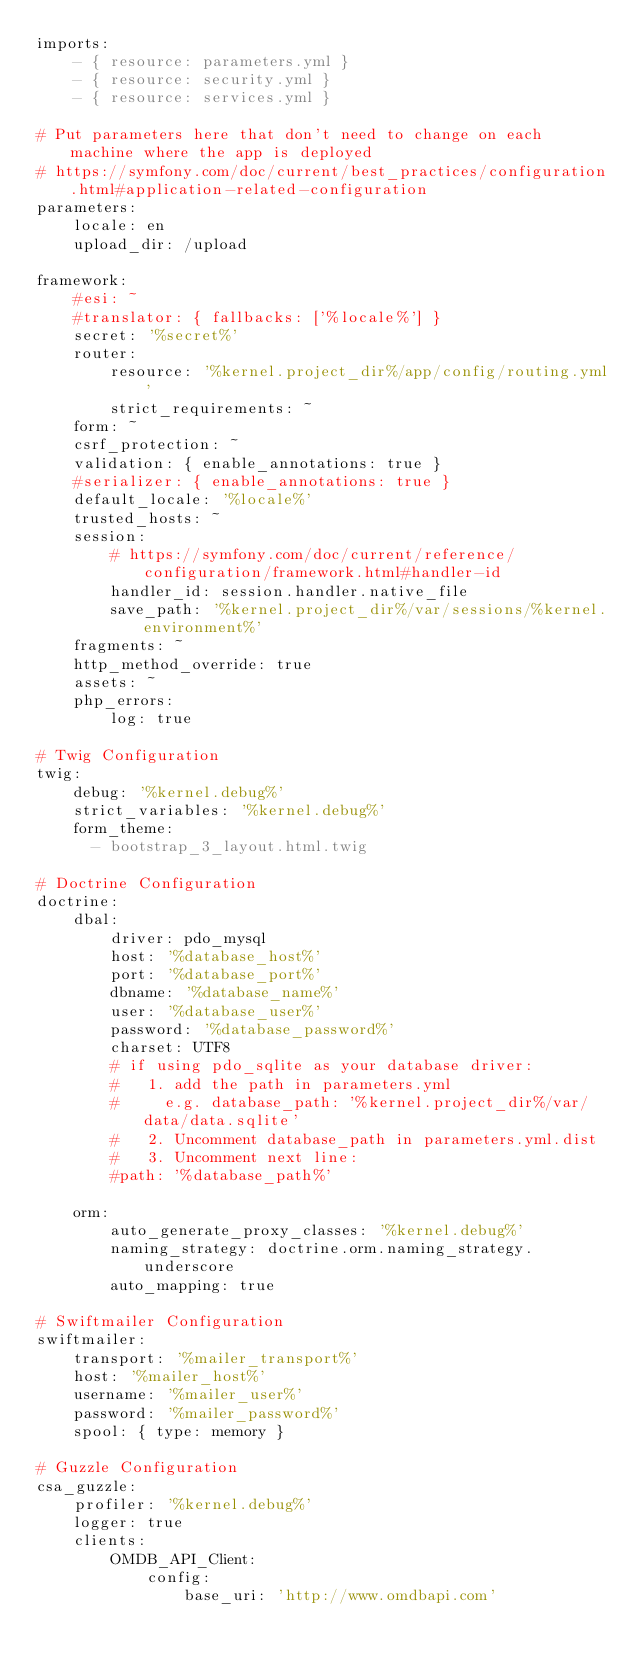Convert code to text. <code><loc_0><loc_0><loc_500><loc_500><_YAML_>imports:
    - { resource: parameters.yml }
    - { resource: security.yml }
    - { resource: services.yml }

# Put parameters here that don't need to change on each machine where the app is deployed
# https://symfony.com/doc/current/best_practices/configuration.html#application-related-configuration
parameters:
    locale: en
    upload_dir: /upload

framework:
    #esi: ~
    #translator: { fallbacks: ['%locale%'] }
    secret: '%secret%'
    router:
        resource: '%kernel.project_dir%/app/config/routing.yml'
        strict_requirements: ~
    form: ~
    csrf_protection: ~
    validation: { enable_annotations: true }
    #serializer: { enable_annotations: true }
    default_locale: '%locale%'
    trusted_hosts: ~
    session:
        # https://symfony.com/doc/current/reference/configuration/framework.html#handler-id
        handler_id: session.handler.native_file
        save_path: '%kernel.project_dir%/var/sessions/%kernel.environment%'
    fragments: ~
    http_method_override: true
    assets: ~
    php_errors:
        log: true

# Twig Configuration
twig:
    debug: '%kernel.debug%'
    strict_variables: '%kernel.debug%'
    form_theme:
      - bootstrap_3_layout.html.twig

# Doctrine Configuration
doctrine:
    dbal:
        driver: pdo_mysql
        host: '%database_host%'
        port: '%database_port%'
        dbname: '%database_name%'
        user: '%database_user%'
        password: '%database_password%'
        charset: UTF8
        # if using pdo_sqlite as your database driver:
        #   1. add the path in parameters.yml
        #     e.g. database_path: '%kernel.project_dir%/var/data/data.sqlite'
        #   2. Uncomment database_path in parameters.yml.dist
        #   3. Uncomment next line:
        #path: '%database_path%'

    orm:
        auto_generate_proxy_classes: '%kernel.debug%'
        naming_strategy: doctrine.orm.naming_strategy.underscore
        auto_mapping: true

# Swiftmailer Configuration
swiftmailer:
    transport: '%mailer_transport%'
    host: '%mailer_host%'
    username: '%mailer_user%'
    password: '%mailer_password%'
    spool: { type: memory }

# Guzzle Configuration
csa_guzzle:
    profiler: '%kernel.debug%'
    logger: true
    clients:
        OMDB_API_Client:
            config:
                base_uri: 'http://www.omdbapi.com'</code> 